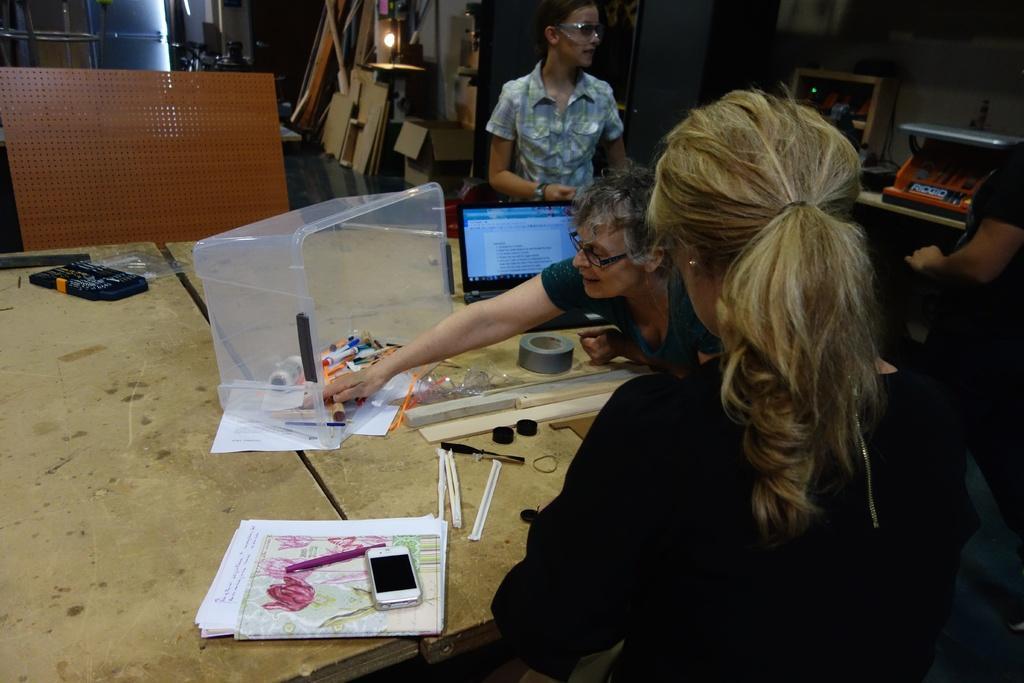Could you give a brief overview of what you see in this image? In the image in the center we can see three persons. Two persons were sitting and one person she is standing. In front of them we can see the table ,on table we can see some objects. And coming to the background we can see the light,tools and wall. 